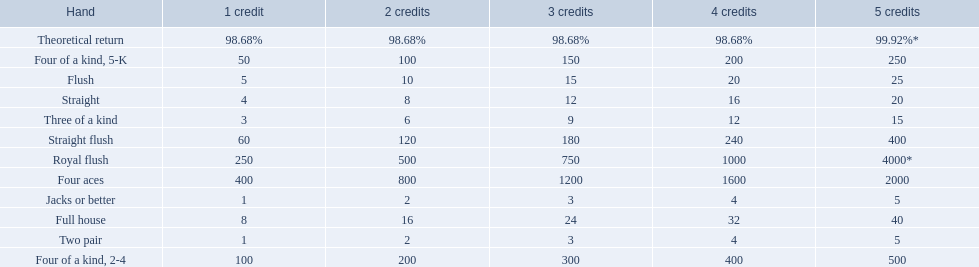What is the higher amount of points for one credit you can get from the best four of a kind 100. What type is it? Four of a kind, 2-4. 